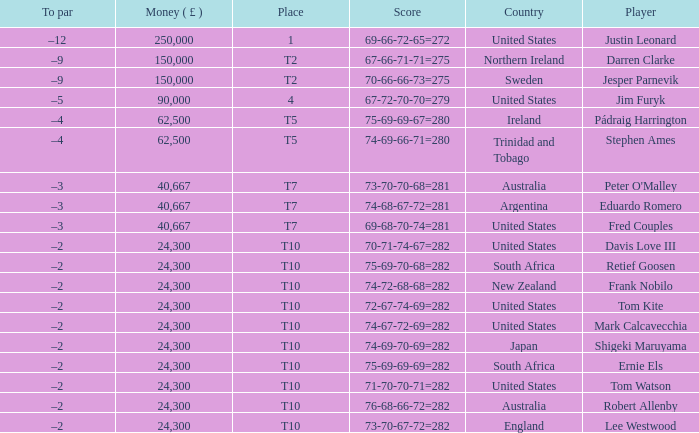How much money has been won by Stephen Ames? 62500.0. 